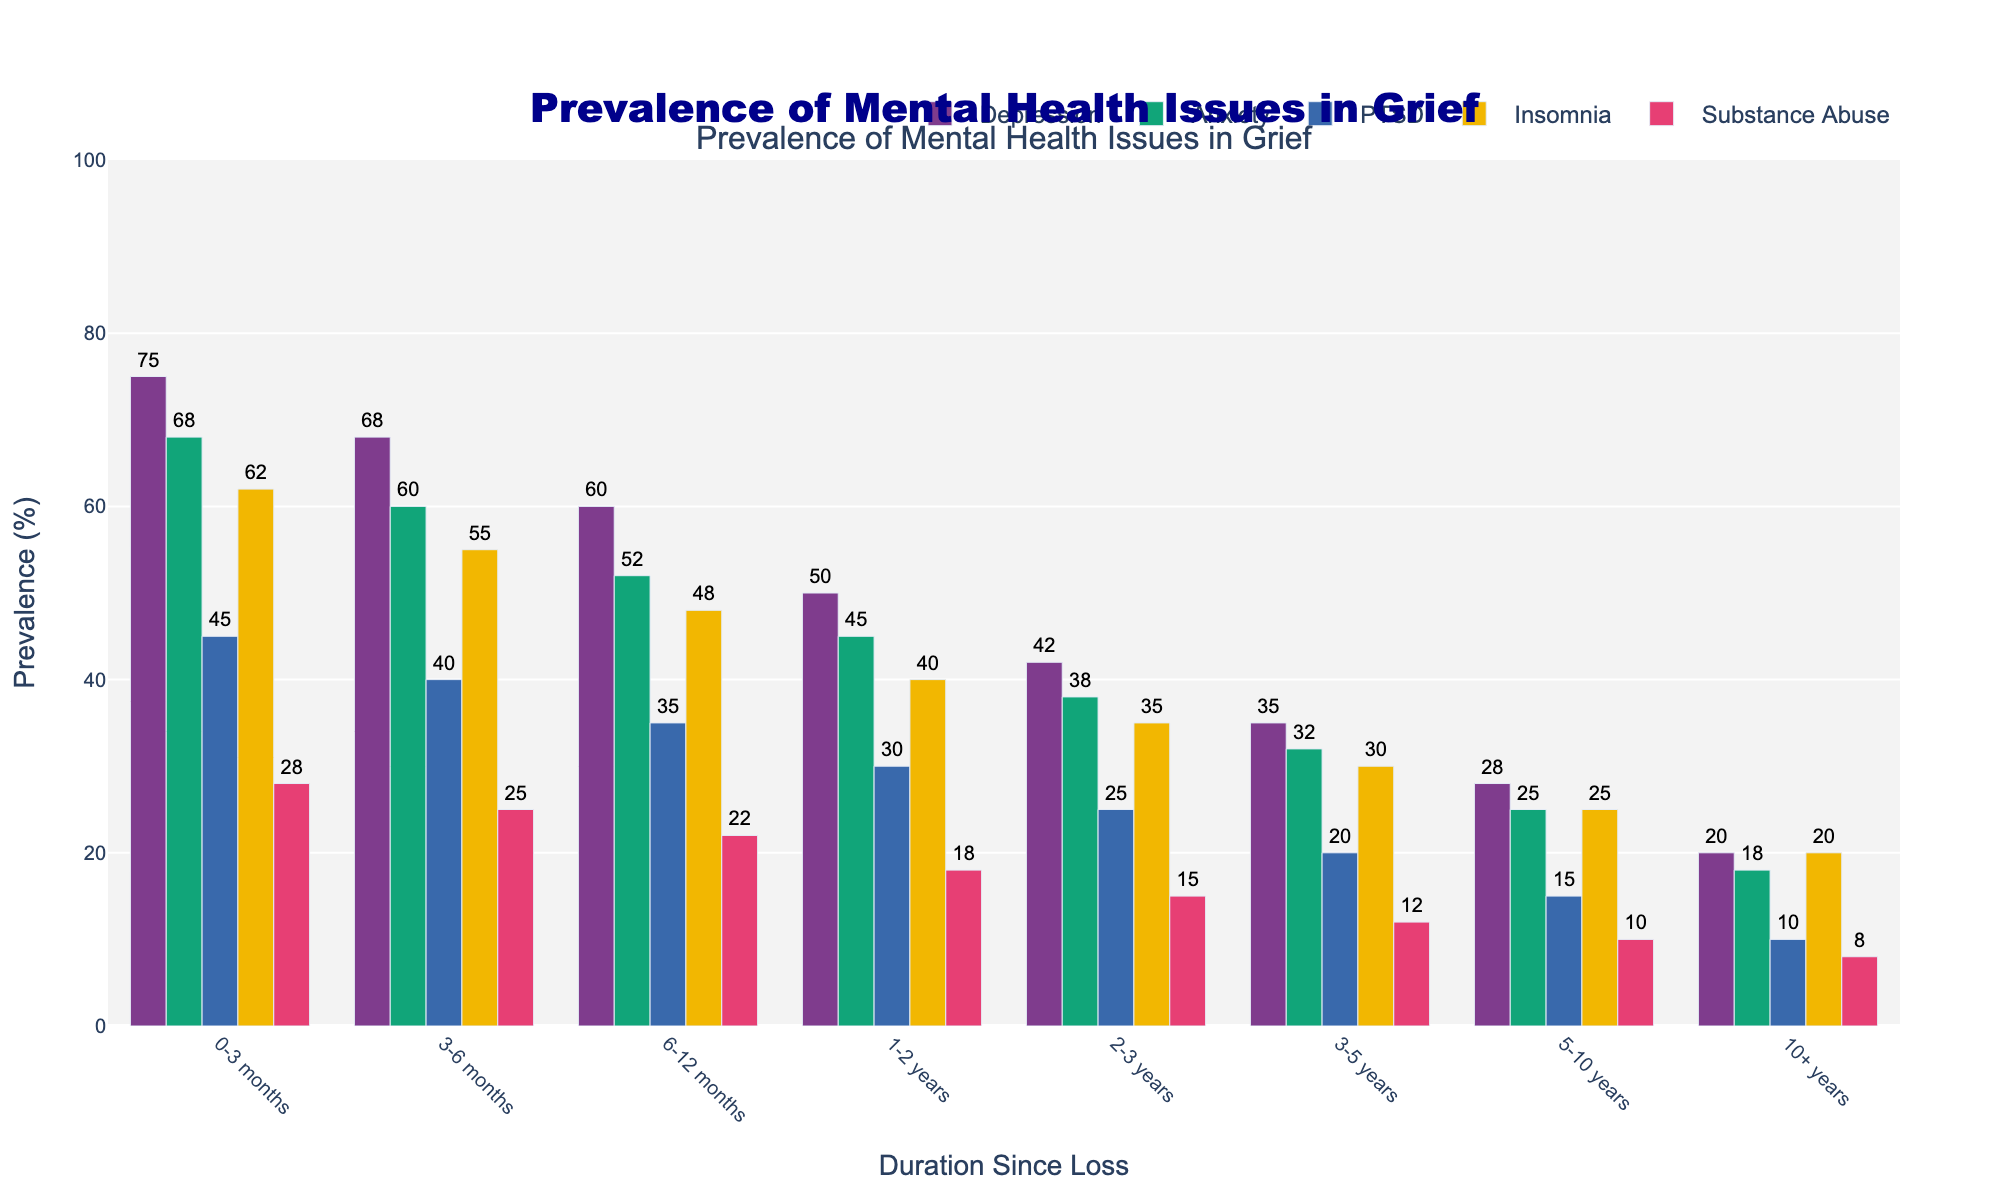Which mental health issue has the highest prevalence in the 0-3 months duration? Look at the bars for the 0-3 months duration and identify the tallest one. The tallest bar represents Depression with a value of 75%.
Answer: Depression How does the prevalence of PTSD in the 3-6 months duration compare to the 6-12 months duration? First, find the PTSD values for the 3-6 months (40%) and the 6-12 months (35%). Then, compare them to see that 40% is greater than 35%.
Answer: PTSD is greater in 3-6 months What's the total prevalence of Anxiety and Insomnia in the 1-2 years duration? Locate the values for Anxiety (45%) and Insomnia (40%) in the 1-2 years duration. Sum them up: 45 + 40 = 85.
Answer: 85% What's the average prevalence of Depression over all durations? Sum up all Depression values: 75 + 68 + 60 + 50 + 42 + 35 + 28 + 20 = 378. Divide by the number of durations (8): 378 / 8 = 47.25.
Answer: 47.25% Which duration shows the highest prevalence of Insomnia? Identify the tallest bar for Insomnia across all durations. The highest value is 62% in the 0-3 months duration.
Answer: 0-3 months How does the prevalence of Substance Abuse in 5-10 years compare to that in 10+ years? Identify the Substance Abuse values for 5-10 years (10%) and 10+ years (8%). Compare to see that 10% is greater than 8%.
Answer: Substance Abuse is greater in 5-10 years By how much does the prevalence of Anxiety decrease from 0-3 months to 2-3 years? Subtract the Anxiety value for 2-3 years (38%) from the value for 0-3 months (68%): 68 - 38 = 30.
Answer: 30% What's the difference in prevalence of PTSD between 3-5 years and 5-10 years? Identify the PTSD values for 3-5 years (20%) and 5-10 years (15%). Subtract: 20 - 15 = 5.
Answer: 5% During which duration is Depression approximately half of its initial prevalence in 0-3 months? Look for a duration where Depression is close to half of 75% (37.5%). The closest value is 35% in the 3-5 years duration.
Answer: 3-5 years 